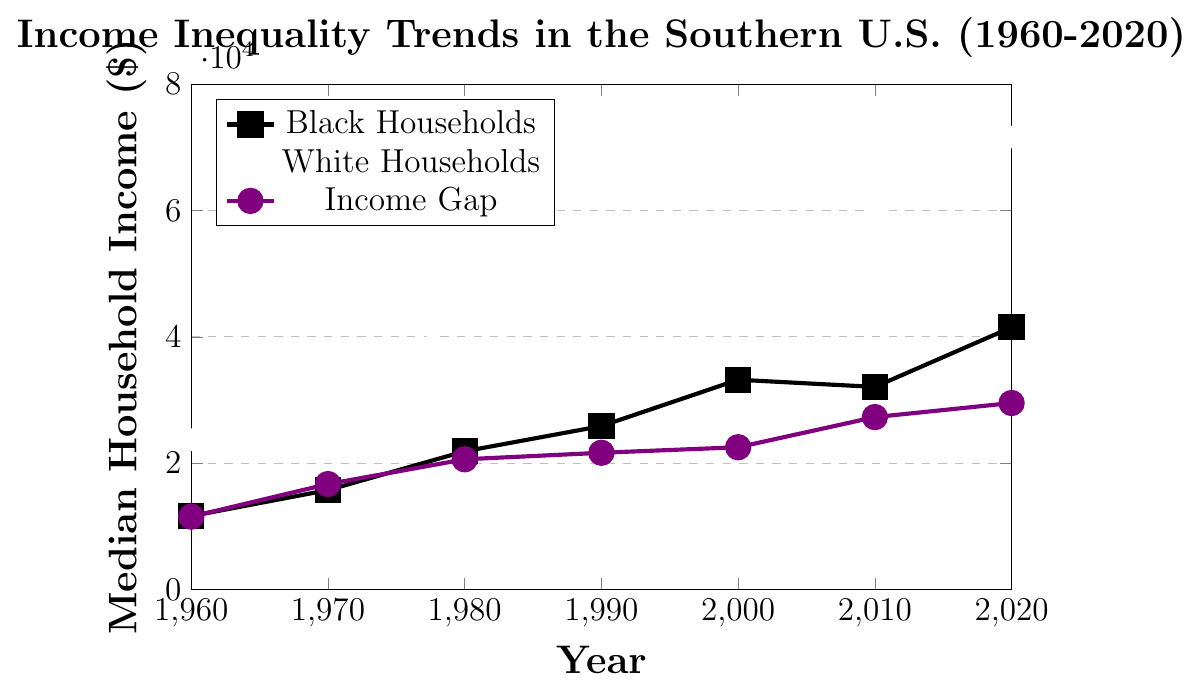which year had the smallest income gap between Black and White households? To find the smallest income gap, we look at the Income Gap ($) plot and identify the lowest point. The lowest value of the income gap is in 1960 with $11529.
Answer: 1960 What was the income gap difference between 1960 and 2020? The income gap in 1960 was $11529 and in 2020 it was $29520. The difference is $29520 - $11529.
Answer: $17991 In which year did Black households experience the most significant increase in median income compared to the previous decade? By examining the Black Household Median Income plot, the largest increase is from 1970 ($15735) to 1980 ($21879). The increase is $21879 - $15735.
Answer: 1980 What is the average median income of White households over the years presented? To find the average, sum up all values for White Household Median Income ($23157, $32427, $42492, $47516, $55724, $59361, $71031) and divide by the number of years (7).
Answer: $47329.71 In which decade did the income gap increase the most? By observing the Income Gap ($) plot, the highest increase is from 2000 ($22520) to 2010 ($27293). The increase is $27293 - $22520.
Answer: 2000-2010 How does the increase in median income for White households from 1980 to 1990 compare to the increase for Black households in the same period? For White households, the increase from 1980 ($42492) to 1990 ($47516) is $47516 - $42492. For Black households, the increase from 1980 ($21879) to 1990 ($25872) is $25872 - $21879. Comparing these two increases shows that White households experienced a larger increase.
Answer: White households had a larger increase Which group had a higher median income in the year 2000, and by how much? By comparing the points on the graph for 2000, White household median income ($55724) is higher than Black household median income ($33204) by $55724 - $33204.
Answer: White households by $22520 What has been the overall trend for the income gap from 1960 to 2020? Looking at the Income Gap ($) plot, it shows a steady increase from $11529 in 1960 to $29520 in 2020. This indicates a widening gap over time.
Answer: Widening gap What was the relative percentage increase in median income for Black households from 1960 to 2020? The percentage increase is calculated as [(41511 - 11628) / 11628] * 100%.
Answer: 257% Between 1960 and 1980, which group saw a higher rate of increase in median household income? Calculating the rate of increase for each: Black households went from $11628 to $21879, and White households went from $23157 to $42492. The rate for Black households is [(21879 - 11628) / 11628] * 100% and for White households is [(42492 - 23157) / 23157] * 100%. Comparing these two rates shows that Black households had a higher rate of increase.
Answer: Black households 